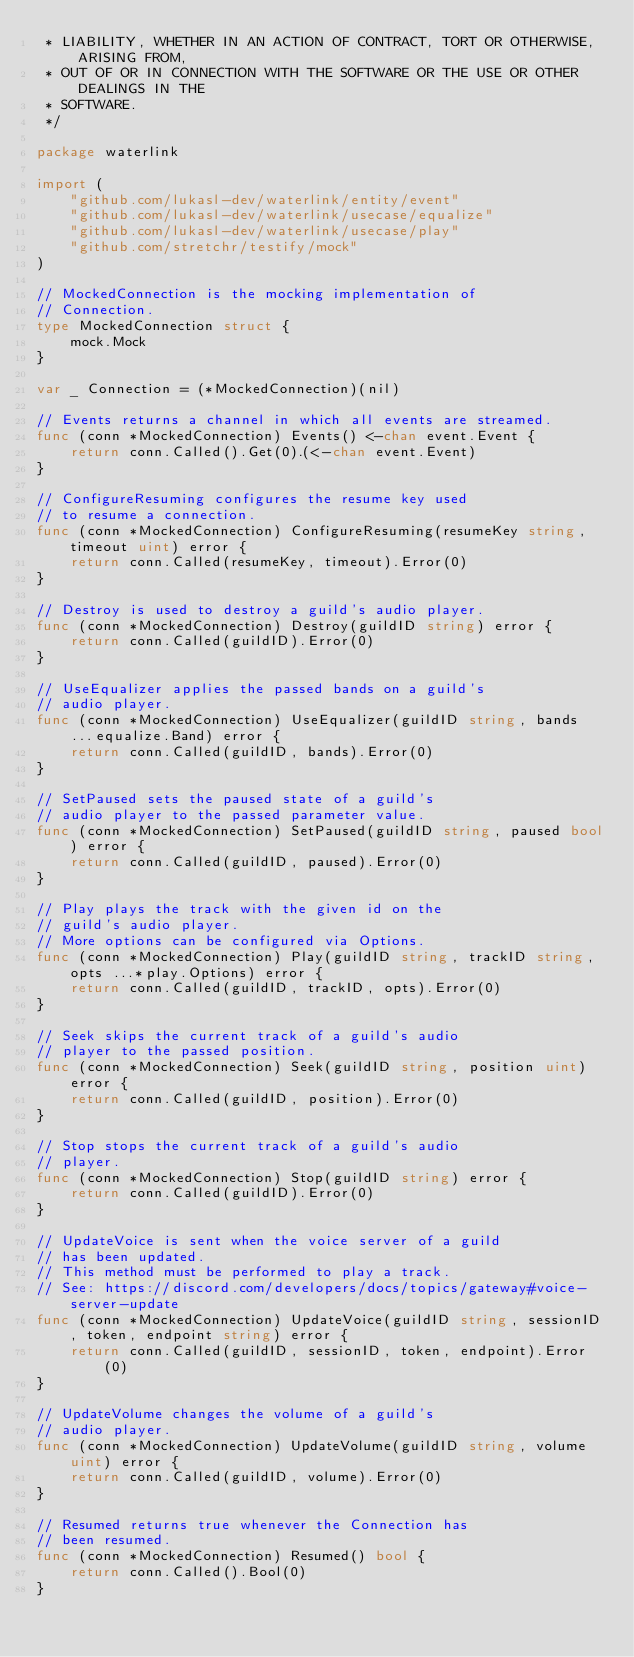Convert code to text. <code><loc_0><loc_0><loc_500><loc_500><_Go_> * LIABILITY, WHETHER IN AN ACTION OF CONTRACT, TORT OR OTHERWISE, ARISING FROM,
 * OUT OF OR IN CONNECTION WITH THE SOFTWARE OR THE USE OR OTHER DEALINGS IN THE
 * SOFTWARE.
 */

package waterlink

import (
	"github.com/lukasl-dev/waterlink/entity/event"
	"github.com/lukasl-dev/waterlink/usecase/equalize"
	"github.com/lukasl-dev/waterlink/usecase/play"
	"github.com/stretchr/testify/mock"
)

// MockedConnection is the mocking implementation of
// Connection.
type MockedConnection struct {
	mock.Mock
}

var _ Connection = (*MockedConnection)(nil)

// Events returns a channel in which all events are streamed.
func (conn *MockedConnection) Events() <-chan event.Event {
	return conn.Called().Get(0).(<-chan event.Event)
}

// ConfigureResuming configures the resume key used
// to resume a connection.
func (conn *MockedConnection) ConfigureResuming(resumeKey string, timeout uint) error {
	return conn.Called(resumeKey, timeout).Error(0)
}

// Destroy is used to destroy a guild's audio player.
func (conn *MockedConnection) Destroy(guildID string) error {
	return conn.Called(guildID).Error(0)
}

// UseEqualizer applies the passed bands on a guild's
// audio player.
func (conn *MockedConnection) UseEqualizer(guildID string, bands ...equalize.Band) error {
	return conn.Called(guildID, bands).Error(0)
}

// SetPaused sets the paused state of a guild's
// audio player to the passed parameter value.
func (conn *MockedConnection) SetPaused(guildID string, paused bool) error {
	return conn.Called(guildID, paused).Error(0)
}

// Play plays the track with the given id on the
// guild's audio player.
// More options can be configured via Options.
func (conn *MockedConnection) Play(guildID string, trackID string, opts ...*play.Options) error {
	return conn.Called(guildID, trackID, opts).Error(0)
}

// Seek skips the current track of a guild's audio
// player to the passed position.
func (conn *MockedConnection) Seek(guildID string, position uint) error {
	return conn.Called(guildID, position).Error(0)
}

// Stop stops the current track of a guild's audio
// player.
func (conn *MockedConnection) Stop(guildID string) error {
	return conn.Called(guildID).Error(0)
}

// UpdateVoice is sent when the voice server of a guild
// has been updated.
// This method must be performed to play a track.
// See: https://discord.com/developers/docs/topics/gateway#voice-server-update
func (conn *MockedConnection) UpdateVoice(guildID string, sessionID, token, endpoint string) error {
	return conn.Called(guildID, sessionID, token, endpoint).Error(0)
}

// UpdateVolume changes the volume of a guild's
// audio player.
func (conn *MockedConnection) UpdateVolume(guildID string, volume uint) error {
	return conn.Called(guildID, volume).Error(0)
}

// Resumed returns true whenever the Connection has
// been resumed.
func (conn *MockedConnection) Resumed() bool {
	return conn.Called().Bool(0)
}
</code> 